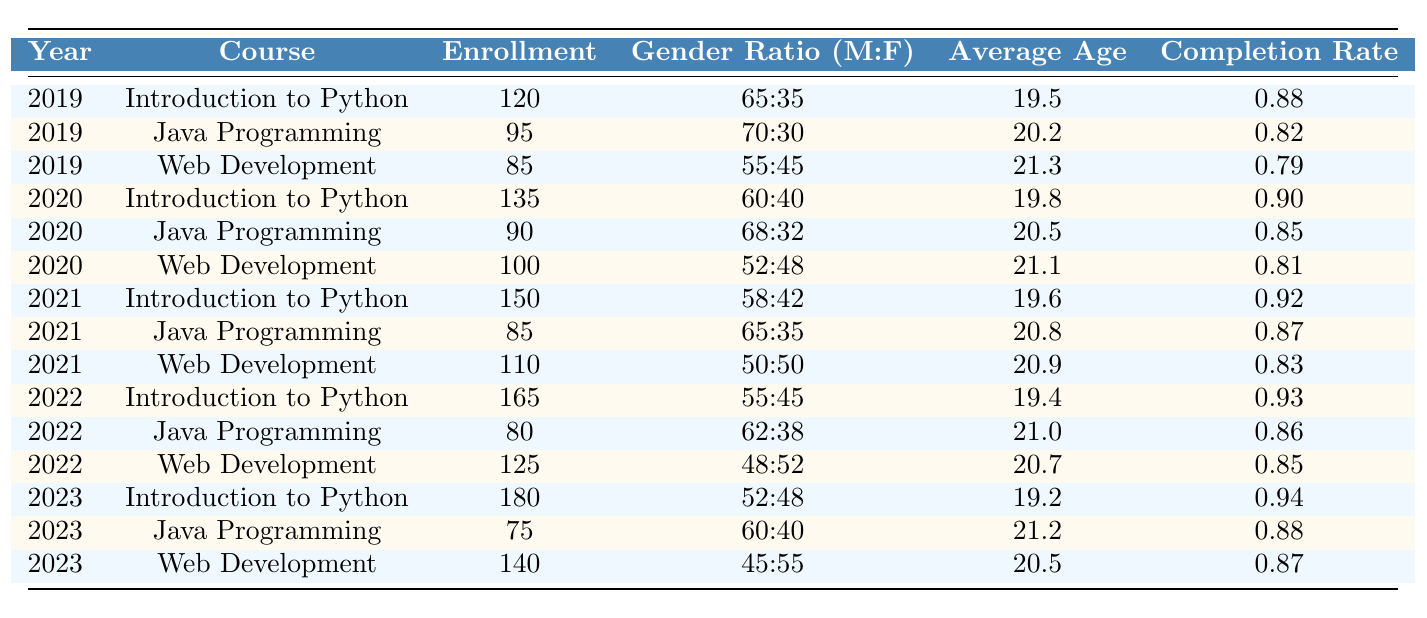What was the enrollment for Web Development in 2021? Referring to the table, I look under the "Year" column for 2021 and find the corresponding enrollment value for the "Web Development" course, which is 110.
Answer: 110 What is the completion rate for the Introduction to Python course in 2023? The table shows that the completion rate under the row for 2023 and the course "Introduction to Python" is 0.94.
Answer: 0.94 Which course had the highest enrollment in 2022? I check the "Enrollment" values for all courses in 2022. The values are 165 for "Introduction to Python," 80 for "Java Programming," and 125 for "Web Development." Since 165 is the largest, "Introduction to Python" had the highest enrollment.
Answer: Introduction to Python What is the gender ratio for Java Programming in 2019? Looking under the "Year" column for 2019 and the "Course" column for "Java Programming," I find the gender ratio listed as 70:30.
Answer: 70:30 Which year had the lowest average age among the listed courses? I examine the "Average Age" values across all years: 19.5 (2019), 19.8 (2020), 19.6 (2021), 19.4 (2022), and 19.2 (2023). The lowest is 19.2 in 2023.
Answer: 2023 What is the average enrollment across all years for Web Development? First, I collect the enrollment values for "Web Development": 85 (2019), 100 (2020), 110 (2021), 125 (2022), and 140 (2023). The total is 85 + 100 + 110 + 125 + 140 = 560. There are 5 years, so the average is 560 / 5 = 112.
Answer: 112 Did the enrollment for Java Programming increase or decrease from 2020 to 2023? Checking the enrollment values, I see that in 2020 it was 90 and in 2023 it was 75. Since 75 is less than 90, enrollment decreased.
Answer: Decreased What is the trend in completion rates from 2019 to 2023 for Introduction to Python? The completion rates for Introduction to Python are 0.88 in 2019, 0.90 in 2020, 0.92 in 2021, 0.93 in 2022, and 0.94 in 2023. They are consistently increasing year by year.
Answer: Increasing trend What was the total enrollment across all courses in 2020? I sum up the enrollment values for each course in 2020: 135 (Python) + 90 (Java) + 100 (Web) = 325.
Answer: 325 Was the average age higher for Java Programming or Web Development in 2022? Looking at the "Average Age" for Java Programming in 2022, it's 21.0, while for Web Development it is 20.7. Since 21.0 is greater than 20.7, Java Programming had a higher average age.
Answer: Java Programming 